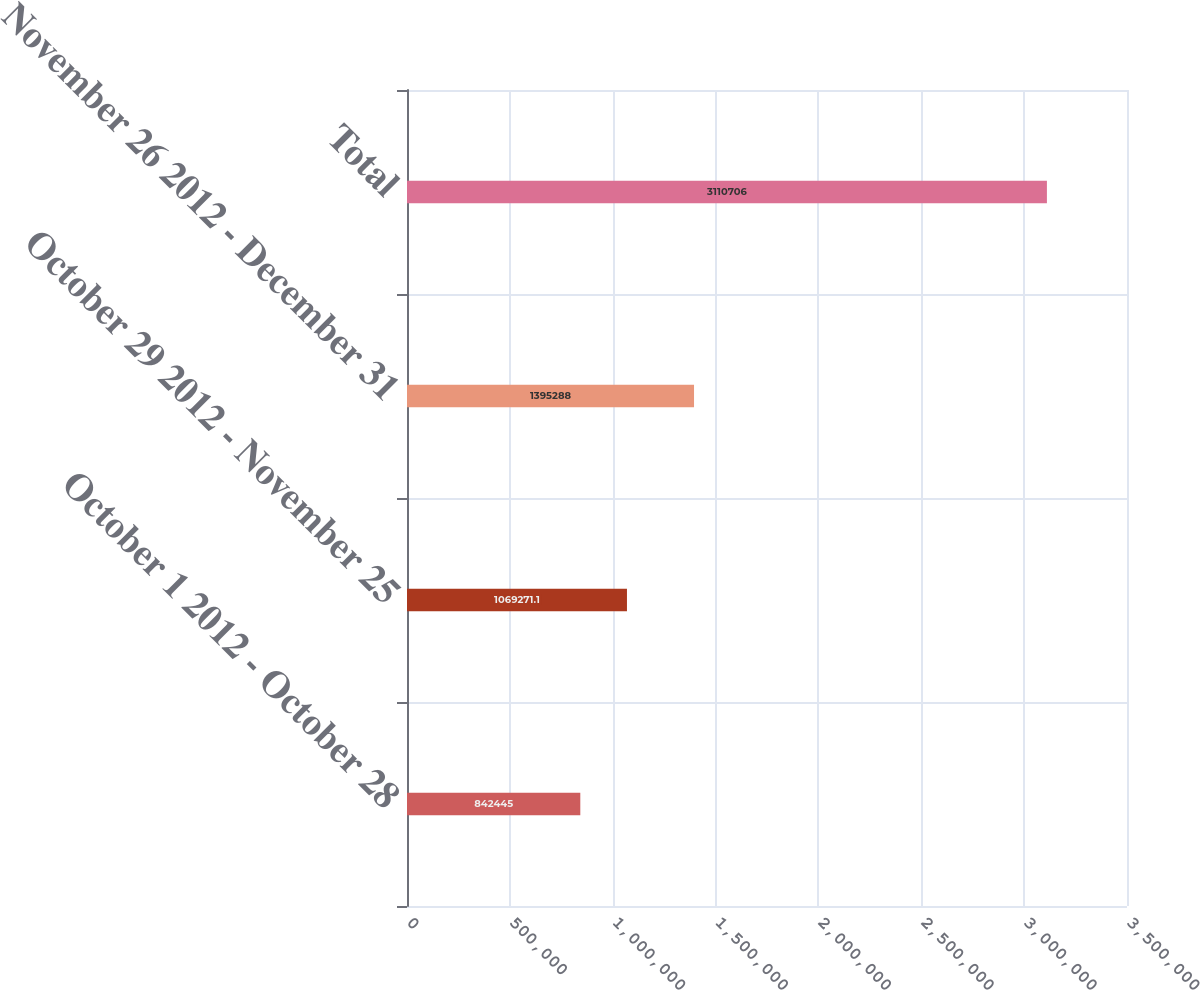Convert chart. <chart><loc_0><loc_0><loc_500><loc_500><bar_chart><fcel>October 1 2012 - October 28<fcel>October 29 2012 - November 25<fcel>November 26 2012 - December 31<fcel>Total<nl><fcel>842445<fcel>1.06927e+06<fcel>1.39529e+06<fcel>3.11071e+06<nl></chart> 